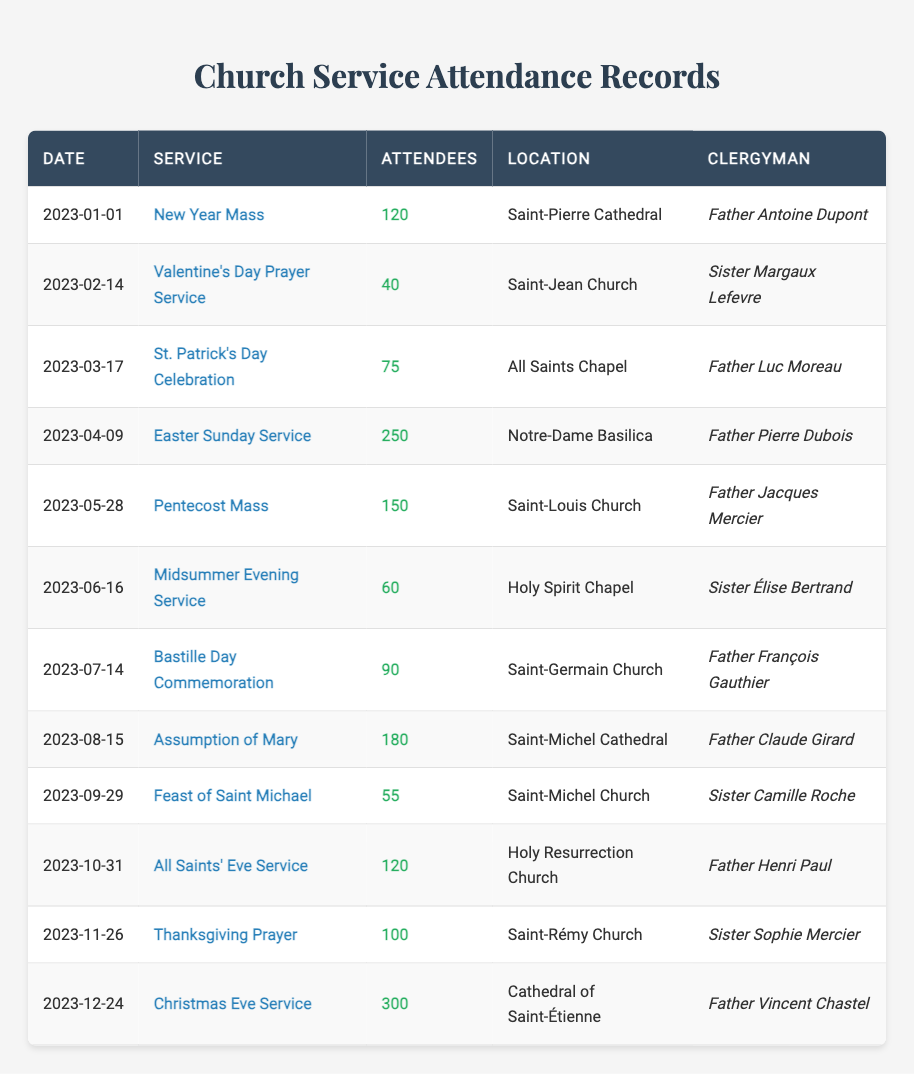What was the highest attendance at a church service in the past year? The highest attendance recorded in the table is on 2023-12-24 for the Christmas Eve Service, with 300 attendees.
Answer: 300 Which clergyman had the least attended service, and what was the attendance number? The least attended service was on 2023-02-14, led by Sister Margaux Lefevre, with 40 attendees.
Answer: Sister Margaux Lefevre, 40 What is the average attendance for the services held at Saint-Michel Cathedral? The services at Saint-Michel Cathedral include the Assumption of Mary with 180 attendees and the Feast of Saint Michael with 55 attendees. The average is (180 + 55) / 2 = 117.5.
Answer: 117.5 Did Father Antoine Dupont lead more than one service in 2023? According to the table, Father Antoine Dupont only led the New Year Mass on 2023-01-01; thus the answer is no.
Answer: No What was the total number of attendees across all the services held in 2023? By summing all the attendance numbers from the table: 120 + 40 + 75 + 250 + 150 + 60 + 90 + 180 + 55 + 120 + 100 + 300 = 1,620. Therefore, the total attendance is 1,620.
Answer: 1620 Which service had the maximum number of attendees per month, and what was the attendance? The Easter Sunday Service on 2023-04-09 had the highest attendance in April with 250 attendees, and no other month had a service surpassing this number.
Answer: Easter Sunday Service, 250 On what date was the Thanksgiving Prayer held, and who was the clergyman? The Thanksgiving Prayer was held on 2023-11-26, and it was led by Sister Sophie Mercier.
Answer: 2023-11-26, Sister Sophie Mercier How many services had more than 100 attendees? The services that had more than 100 attendees are: Easter Sunday Service (250), Pentecost Mass (150), Assumption of Mary (180), Christmas Eve Service (300), and Thanksgiving Prayer (100). This totals to 5 services.
Answer: 5 Which clergyman had a service at Holy Spirit Chapel, and what was the attendance? The service at Holy Spirit Chapel was the Midsummer Evening Service on 2023-06-16, led by Sister Élise Bertrand, with 60 attendees.
Answer: Sister Élise Bertrand, 60 